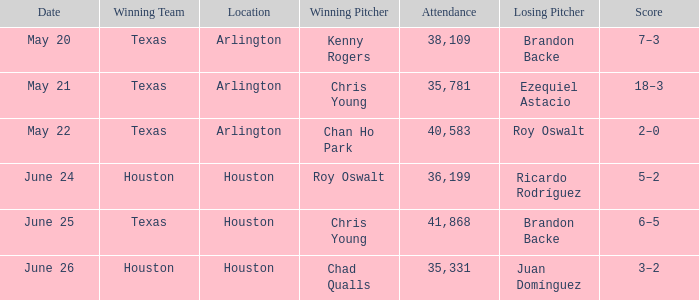Which location has a date of may 21? Arlington. 